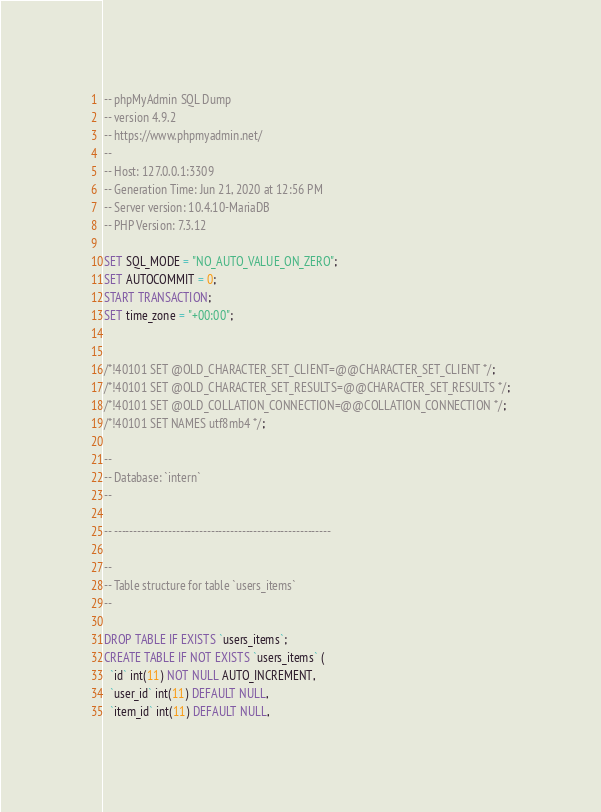<code> <loc_0><loc_0><loc_500><loc_500><_SQL_>-- phpMyAdmin SQL Dump
-- version 4.9.2
-- https://www.phpmyadmin.net/
--
-- Host: 127.0.0.1:3309
-- Generation Time: Jun 21, 2020 at 12:56 PM
-- Server version: 10.4.10-MariaDB
-- PHP Version: 7.3.12

SET SQL_MODE = "NO_AUTO_VALUE_ON_ZERO";
SET AUTOCOMMIT = 0;
START TRANSACTION;
SET time_zone = "+00:00";


/*!40101 SET @OLD_CHARACTER_SET_CLIENT=@@CHARACTER_SET_CLIENT */;
/*!40101 SET @OLD_CHARACTER_SET_RESULTS=@@CHARACTER_SET_RESULTS */;
/*!40101 SET @OLD_COLLATION_CONNECTION=@@COLLATION_CONNECTION */;
/*!40101 SET NAMES utf8mb4 */;

--
-- Database: `intern`
--

-- --------------------------------------------------------

--
-- Table structure for table `users_items`
--

DROP TABLE IF EXISTS `users_items`;
CREATE TABLE IF NOT EXISTS `users_items` (
  `id` int(11) NOT NULL AUTO_INCREMENT,
  `user_id` int(11) DEFAULT NULL,
  `item_id` int(11) DEFAULT NULL,</code> 